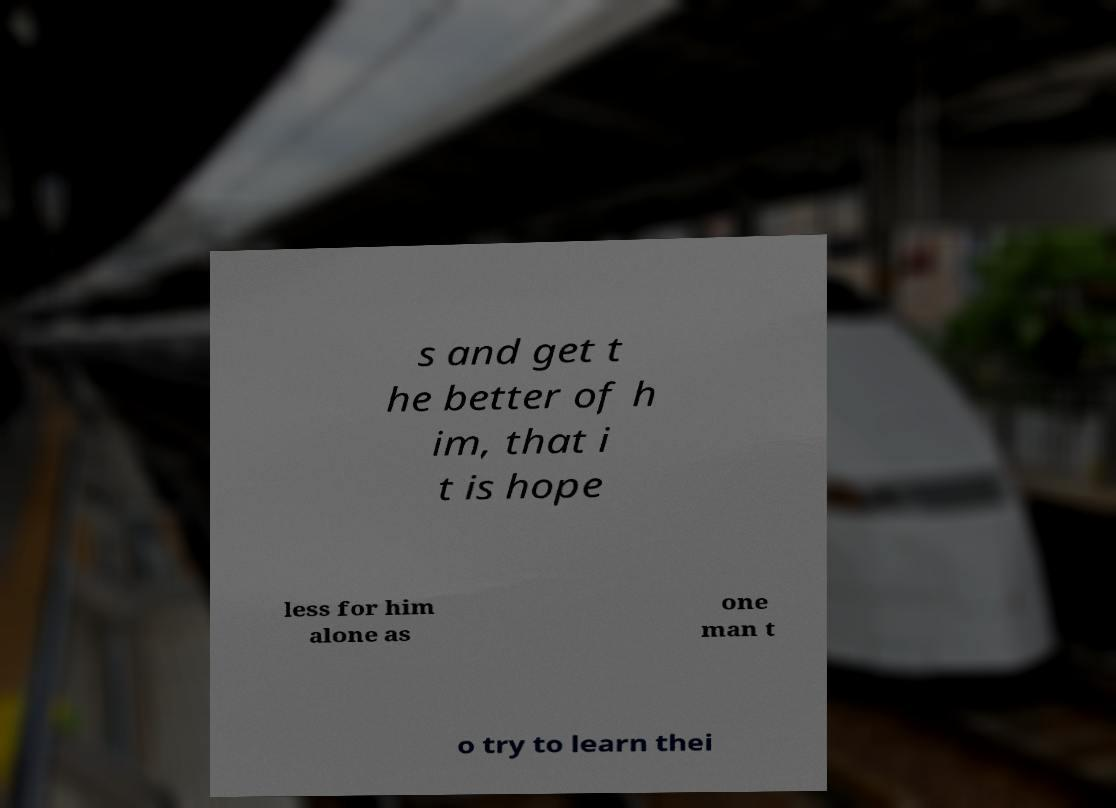There's text embedded in this image that I need extracted. Can you transcribe it verbatim? s and get t he better of h im, that i t is hope less for him alone as one man t o try to learn thei 